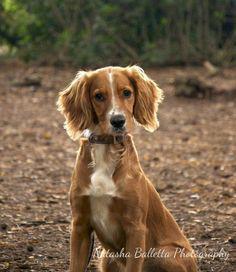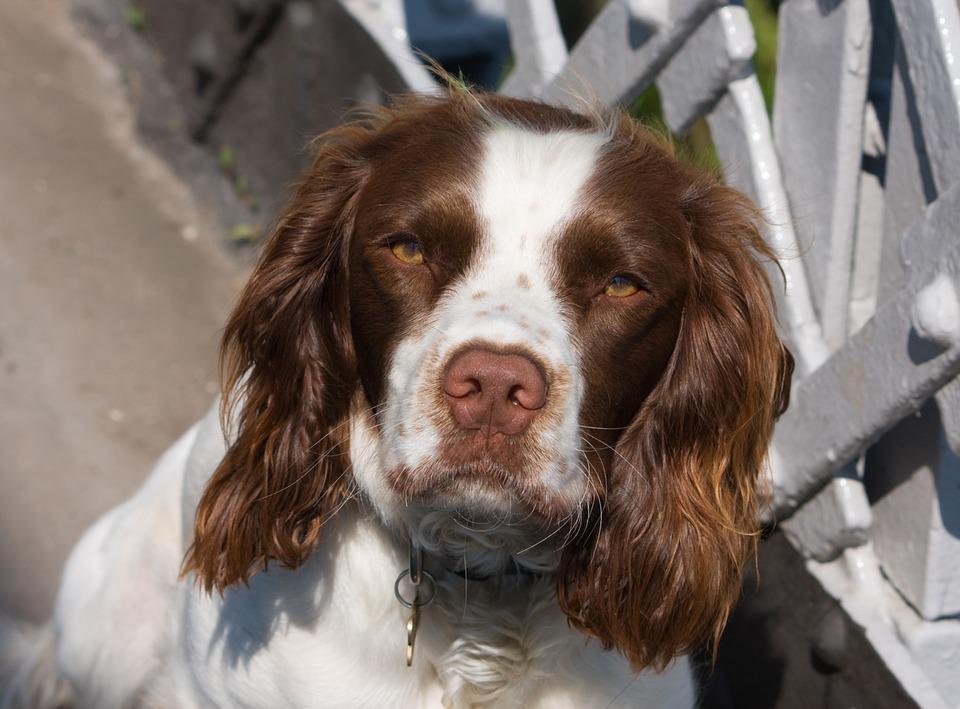The first image is the image on the left, the second image is the image on the right. Examine the images to the left and right. Is the description "At least one dog is wearing a dog tag on its collar." accurate? Answer yes or no. Yes. The first image is the image on the left, the second image is the image on the right. Considering the images on both sides, is "The dog on the right has a charm dangling from its collar, and the dog on the left is sitting upright outdoors with something around its neck." valid? Answer yes or no. Yes. 